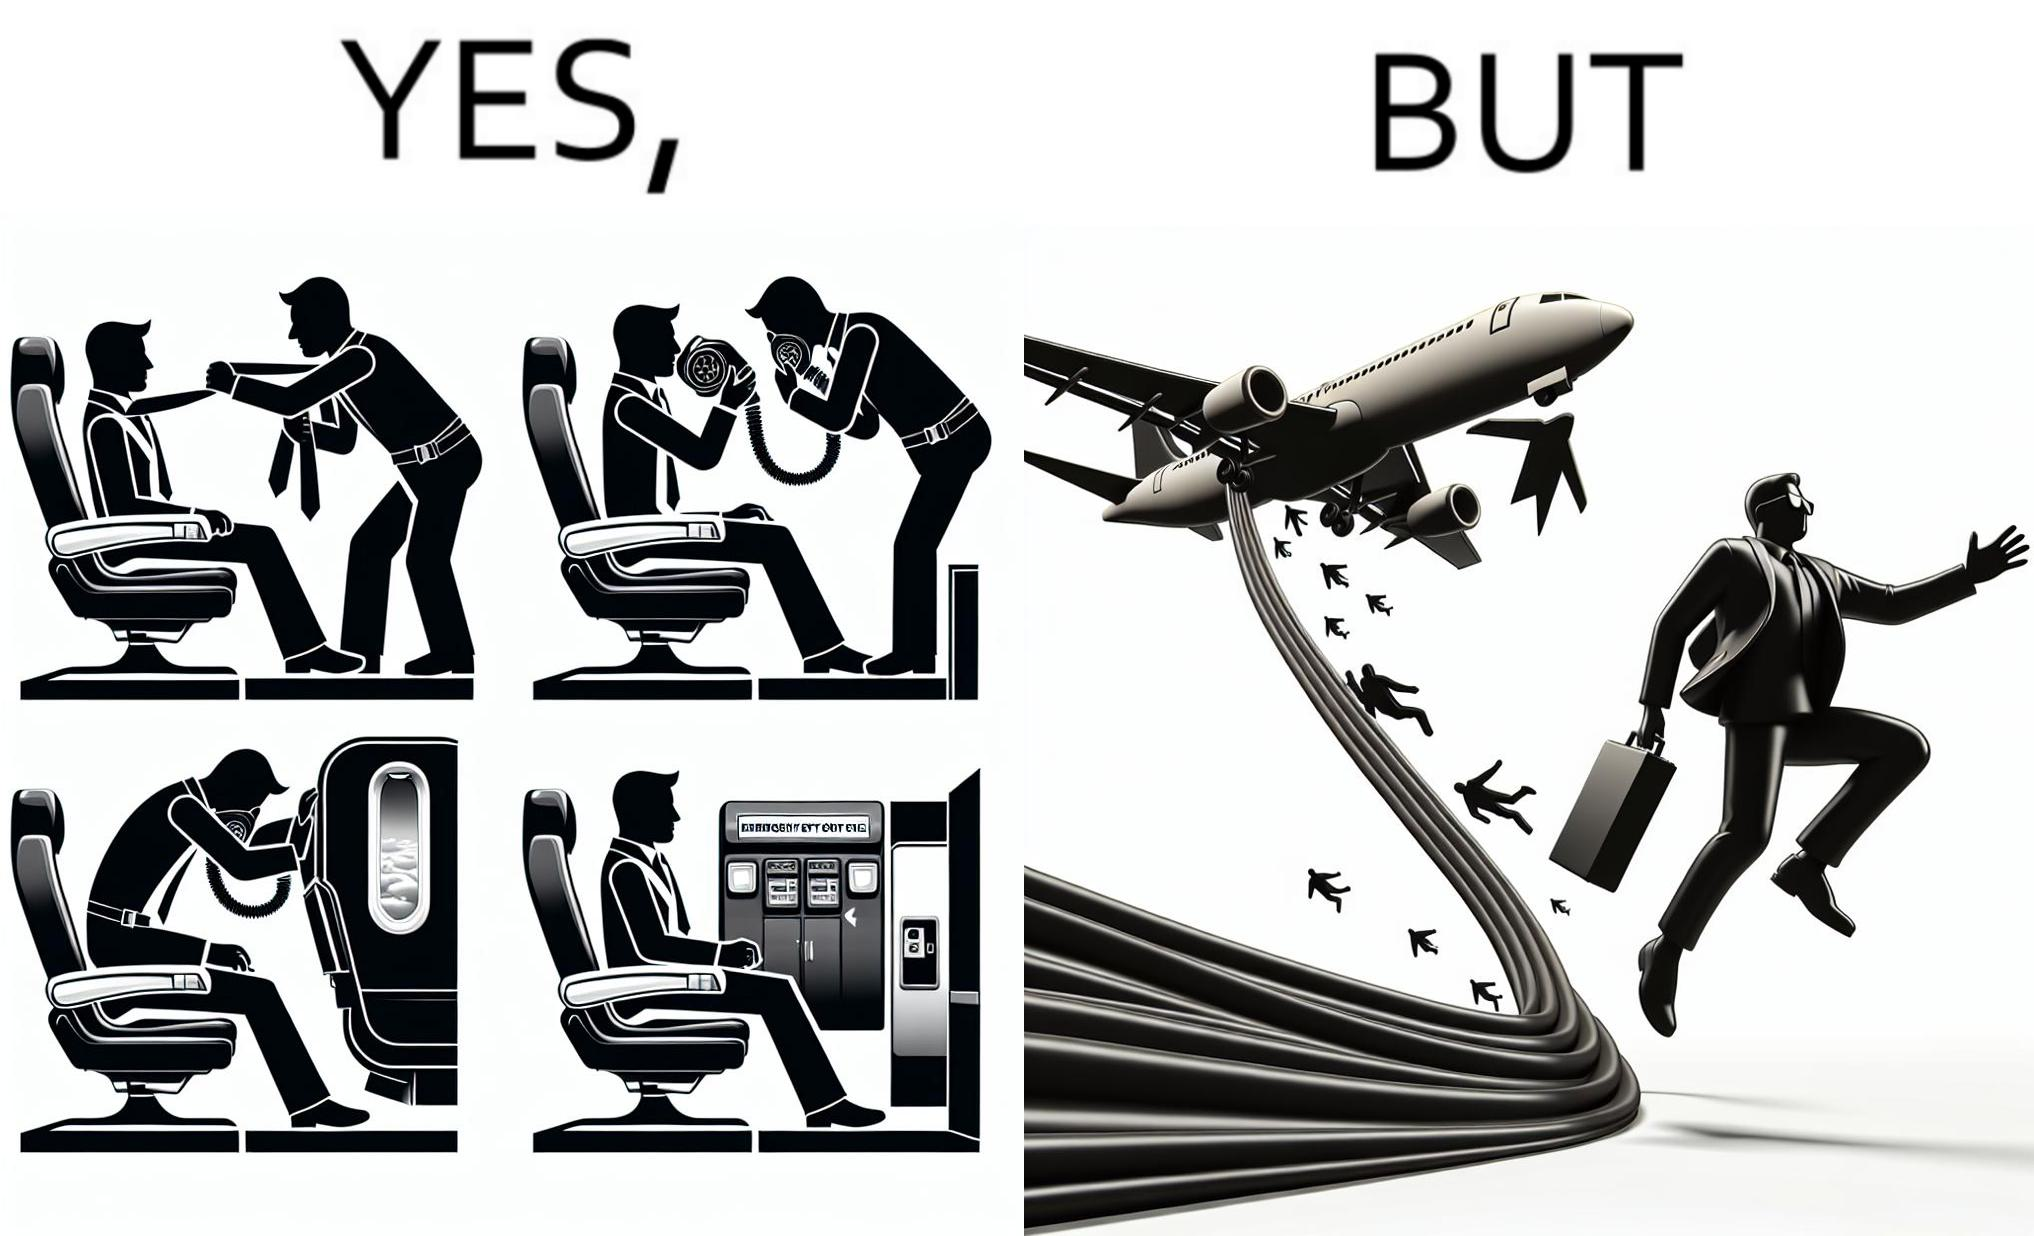Is this a satirical image? Yes, this image is satirical. 